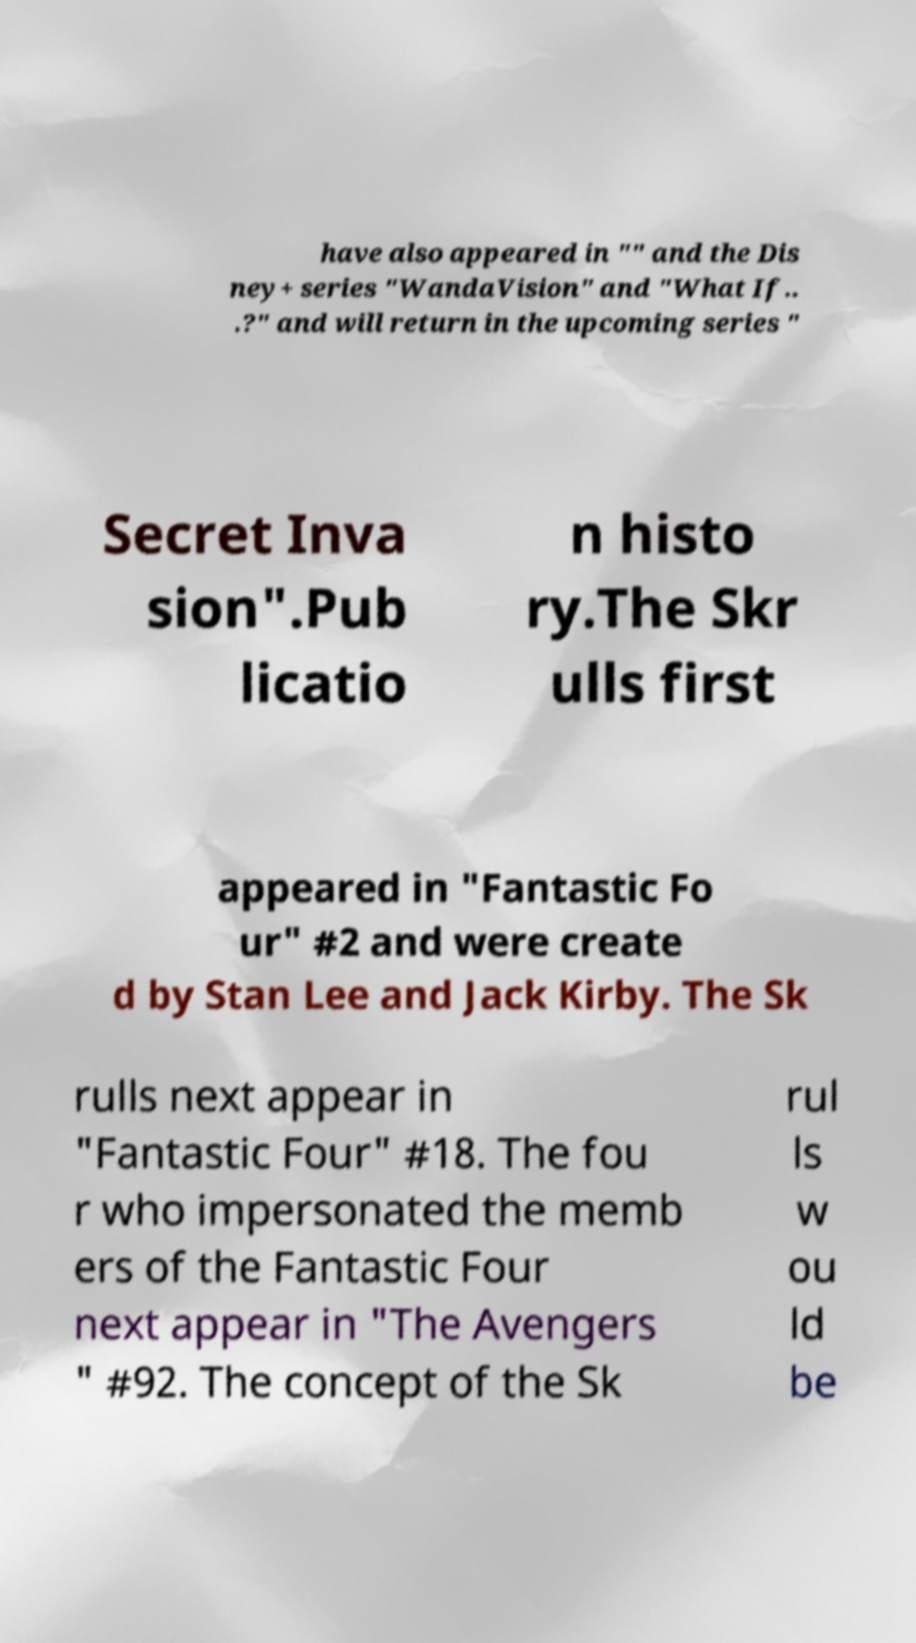For documentation purposes, I need the text within this image transcribed. Could you provide that? have also appeared in "" and the Dis ney+ series "WandaVision" and "What If.. .?" and will return in the upcoming series " Secret Inva sion".Pub licatio n histo ry.The Skr ulls first appeared in "Fantastic Fo ur" #2 and were create d by Stan Lee and Jack Kirby. The Sk rulls next appear in "Fantastic Four" #18. The fou r who impersonated the memb ers of the Fantastic Four next appear in "The Avengers " #92. The concept of the Sk rul ls w ou ld be 